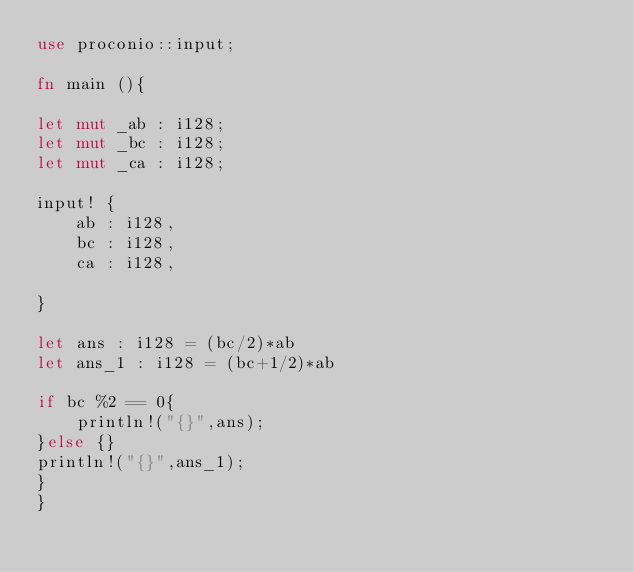<code> <loc_0><loc_0><loc_500><loc_500><_Rust_>use proconio::input;

fn main (){

let mut _ab : i128;
let mut _bc : i128;
let mut _ca : i128;

input! {
    ab : i128,
    bc : i128,
    ca : i128,

}

let ans : i128 = (bc/2)*ab
let ans_1 : i128 = (bc+1/2)*ab

if bc %2 == 0{
    println!("{}",ans);
}else {}
println!("{}",ans_1);
}
}</code> 